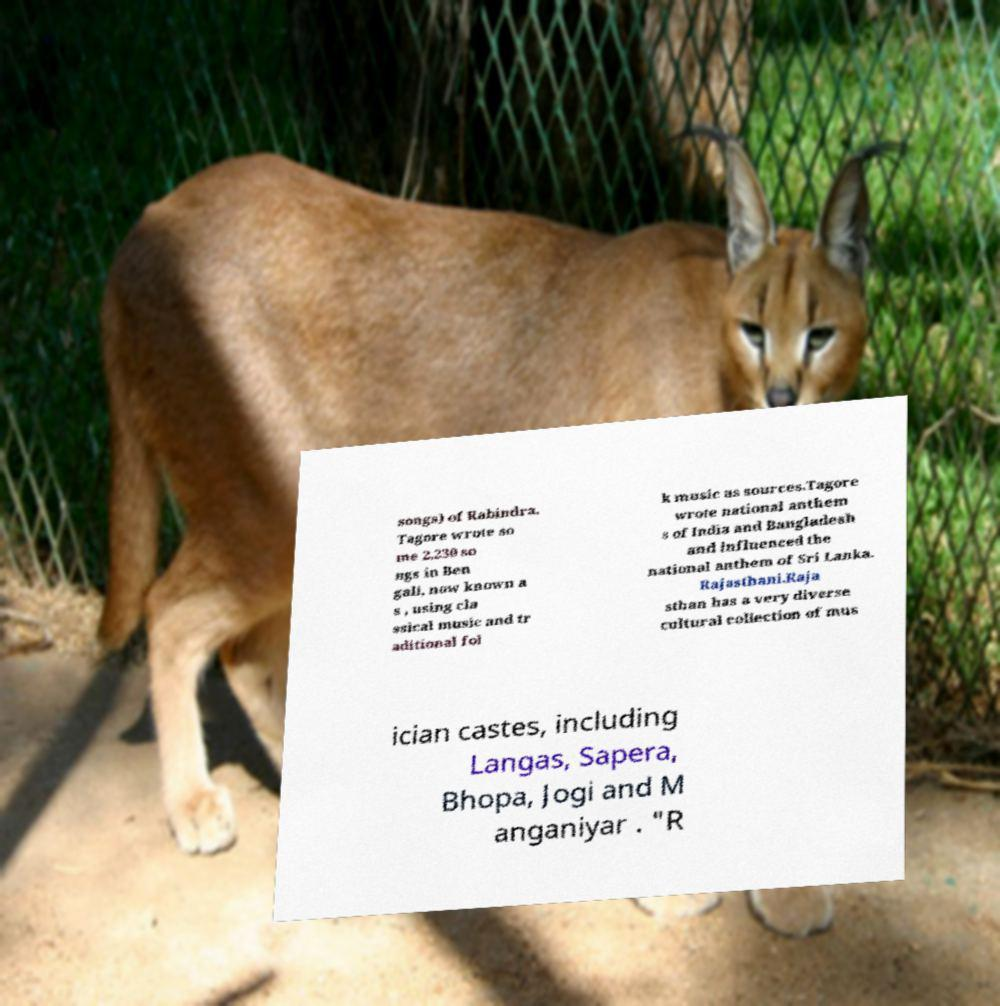There's text embedded in this image that I need extracted. Can you transcribe it verbatim? songs) of Rabindra. Tagore wrote so me 2,230 so ngs in Ben gali, now known a s , using cla ssical music and tr aditional fol k music as sources.Tagore wrote national anthem s of India and Bangladesh and influenced the national anthem of Sri Lanka. Rajasthani.Raja sthan has a very diverse cultural collection of mus ician castes, including Langas, Sapera, Bhopa, Jogi and M anganiyar . "R 